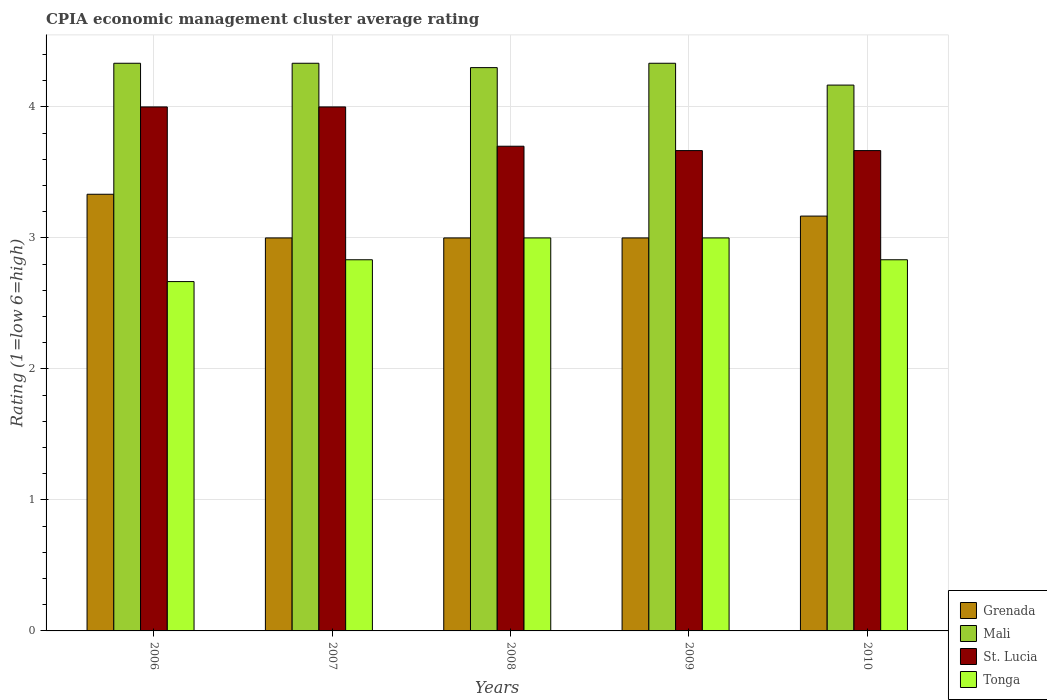How many different coloured bars are there?
Your answer should be very brief. 4. Are the number of bars per tick equal to the number of legend labels?
Keep it short and to the point. Yes. How many bars are there on the 2nd tick from the left?
Provide a short and direct response. 4. What is the CPIA rating in Mali in 2010?
Offer a terse response. 4.17. Across all years, what is the maximum CPIA rating in St. Lucia?
Provide a short and direct response. 4. In which year was the CPIA rating in Mali minimum?
Provide a short and direct response. 2010. What is the total CPIA rating in Tonga in the graph?
Give a very brief answer. 14.33. What is the difference between the CPIA rating in Mali in 2006 and that in 2008?
Give a very brief answer. 0.03. What is the difference between the CPIA rating in Grenada in 2008 and the CPIA rating in Tonga in 2007?
Offer a terse response. 0.17. What is the average CPIA rating in Mali per year?
Offer a very short reply. 4.29. In the year 2006, what is the difference between the CPIA rating in Mali and CPIA rating in Tonga?
Ensure brevity in your answer.  1.67. What is the ratio of the CPIA rating in Grenada in 2008 to that in 2010?
Ensure brevity in your answer.  0.95. What is the difference between the highest and the second highest CPIA rating in Grenada?
Your response must be concise. 0.17. What is the difference between the highest and the lowest CPIA rating in Tonga?
Provide a succinct answer. 0.33. In how many years, is the CPIA rating in Tonga greater than the average CPIA rating in Tonga taken over all years?
Your response must be concise. 2. Is the sum of the CPIA rating in St. Lucia in 2006 and 2008 greater than the maximum CPIA rating in Mali across all years?
Offer a very short reply. Yes. Is it the case that in every year, the sum of the CPIA rating in Grenada and CPIA rating in Tonga is greater than the sum of CPIA rating in St. Lucia and CPIA rating in Mali?
Keep it short and to the point. No. What does the 1st bar from the left in 2007 represents?
Make the answer very short. Grenada. What does the 4th bar from the right in 2006 represents?
Your answer should be very brief. Grenada. Are all the bars in the graph horizontal?
Give a very brief answer. No. What is the difference between two consecutive major ticks on the Y-axis?
Ensure brevity in your answer.  1. Are the values on the major ticks of Y-axis written in scientific E-notation?
Ensure brevity in your answer.  No. Does the graph contain any zero values?
Provide a succinct answer. No. Does the graph contain grids?
Make the answer very short. Yes. Where does the legend appear in the graph?
Keep it short and to the point. Bottom right. How are the legend labels stacked?
Offer a terse response. Vertical. What is the title of the graph?
Provide a succinct answer. CPIA economic management cluster average rating. What is the label or title of the Y-axis?
Ensure brevity in your answer.  Rating (1=low 6=high). What is the Rating (1=low 6=high) in Grenada in 2006?
Give a very brief answer. 3.33. What is the Rating (1=low 6=high) in Mali in 2006?
Your answer should be very brief. 4.33. What is the Rating (1=low 6=high) in St. Lucia in 2006?
Give a very brief answer. 4. What is the Rating (1=low 6=high) in Tonga in 2006?
Your answer should be very brief. 2.67. What is the Rating (1=low 6=high) in Mali in 2007?
Your answer should be very brief. 4.33. What is the Rating (1=low 6=high) in St. Lucia in 2007?
Your response must be concise. 4. What is the Rating (1=low 6=high) in Tonga in 2007?
Offer a very short reply. 2.83. What is the Rating (1=low 6=high) in Mali in 2008?
Give a very brief answer. 4.3. What is the Rating (1=low 6=high) in Mali in 2009?
Offer a terse response. 4.33. What is the Rating (1=low 6=high) in St. Lucia in 2009?
Your answer should be compact. 3.67. What is the Rating (1=low 6=high) in Tonga in 2009?
Make the answer very short. 3. What is the Rating (1=low 6=high) of Grenada in 2010?
Give a very brief answer. 3.17. What is the Rating (1=low 6=high) of Mali in 2010?
Keep it short and to the point. 4.17. What is the Rating (1=low 6=high) of St. Lucia in 2010?
Make the answer very short. 3.67. What is the Rating (1=low 6=high) in Tonga in 2010?
Keep it short and to the point. 2.83. Across all years, what is the maximum Rating (1=low 6=high) of Grenada?
Provide a succinct answer. 3.33. Across all years, what is the maximum Rating (1=low 6=high) in Mali?
Keep it short and to the point. 4.33. Across all years, what is the minimum Rating (1=low 6=high) of Mali?
Give a very brief answer. 4.17. Across all years, what is the minimum Rating (1=low 6=high) of St. Lucia?
Offer a terse response. 3.67. Across all years, what is the minimum Rating (1=low 6=high) of Tonga?
Your answer should be compact. 2.67. What is the total Rating (1=low 6=high) of Mali in the graph?
Keep it short and to the point. 21.47. What is the total Rating (1=low 6=high) in St. Lucia in the graph?
Give a very brief answer. 19.03. What is the total Rating (1=low 6=high) in Tonga in the graph?
Provide a succinct answer. 14.33. What is the difference between the Rating (1=low 6=high) of Grenada in 2006 and that in 2008?
Your answer should be compact. 0.33. What is the difference between the Rating (1=low 6=high) in Mali in 2006 and that in 2008?
Your response must be concise. 0.03. What is the difference between the Rating (1=low 6=high) in St. Lucia in 2006 and that in 2008?
Your response must be concise. 0.3. What is the difference between the Rating (1=low 6=high) in Tonga in 2006 and that in 2008?
Make the answer very short. -0.33. What is the difference between the Rating (1=low 6=high) in Mali in 2006 and that in 2009?
Your answer should be very brief. 0. What is the difference between the Rating (1=low 6=high) in St. Lucia in 2006 and that in 2009?
Ensure brevity in your answer.  0.33. What is the difference between the Rating (1=low 6=high) in Tonga in 2006 and that in 2009?
Keep it short and to the point. -0.33. What is the difference between the Rating (1=low 6=high) in Grenada in 2006 and that in 2010?
Your response must be concise. 0.17. What is the difference between the Rating (1=low 6=high) in Mali in 2006 and that in 2010?
Your answer should be very brief. 0.17. What is the difference between the Rating (1=low 6=high) in St. Lucia in 2006 and that in 2010?
Give a very brief answer. 0.33. What is the difference between the Rating (1=low 6=high) in St. Lucia in 2007 and that in 2008?
Offer a terse response. 0.3. What is the difference between the Rating (1=low 6=high) in Grenada in 2007 and that in 2009?
Keep it short and to the point. 0. What is the difference between the Rating (1=low 6=high) in Grenada in 2007 and that in 2010?
Your response must be concise. -0.17. What is the difference between the Rating (1=low 6=high) in St. Lucia in 2007 and that in 2010?
Your answer should be compact. 0.33. What is the difference between the Rating (1=low 6=high) in Grenada in 2008 and that in 2009?
Provide a short and direct response. 0. What is the difference between the Rating (1=low 6=high) in Mali in 2008 and that in 2009?
Ensure brevity in your answer.  -0.03. What is the difference between the Rating (1=low 6=high) of St. Lucia in 2008 and that in 2009?
Give a very brief answer. 0.03. What is the difference between the Rating (1=low 6=high) in Grenada in 2008 and that in 2010?
Offer a terse response. -0.17. What is the difference between the Rating (1=low 6=high) in Mali in 2008 and that in 2010?
Give a very brief answer. 0.13. What is the difference between the Rating (1=low 6=high) of Grenada in 2009 and that in 2010?
Keep it short and to the point. -0.17. What is the difference between the Rating (1=low 6=high) of Mali in 2009 and that in 2010?
Make the answer very short. 0.17. What is the difference between the Rating (1=low 6=high) in Tonga in 2009 and that in 2010?
Your answer should be compact. 0.17. What is the difference between the Rating (1=low 6=high) of Grenada in 2006 and the Rating (1=low 6=high) of St. Lucia in 2007?
Offer a terse response. -0.67. What is the difference between the Rating (1=low 6=high) in Grenada in 2006 and the Rating (1=low 6=high) in Mali in 2008?
Ensure brevity in your answer.  -0.97. What is the difference between the Rating (1=low 6=high) in Grenada in 2006 and the Rating (1=low 6=high) in St. Lucia in 2008?
Your answer should be very brief. -0.37. What is the difference between the Rating (1=low 6=high) of Grenada in 2006 and the Rating (1=low 6=high) of Tonga in 2008?
Your response must be concise. 0.33. What is the difference between the Rating (1=low 6=high) of Mali in 2006 and the Rating (1=low 6=high) of St. Lucia in 2008?
Offer a terse response. 0.63. What is the difference between the Rating (1=low 6=high) of Grenada in 2006 and the Rating (1=low 6=high) of Mali in 2009?
Give a very brief answer. -1. What is the difference between the Rating (1=low 6=high) of Grenada in 2006 and the Rating (1=low 6=high) of St. Lucia in 2009?
Your answer should be compact. -0.33. What is the difference between the Rating (1=low 6=high) of Grenada in 2006 and the Rating (1=low 6=high) of Tonga in 2009?
Your answer should be very brief. 0.33. What is the difference between the Rating (1=low 6=high) in Mali in 2006 and the Rating (1=low 6=high) in St. Lucia in 2009?
Offer a very short reply. 0.67. What is the difference between the Rating (1=low 6=high) in Mali in 2006 and the Rating (1=low 6=high) in Tonga in 2009?
Offer a very short reply. 1.33. What is the difference between the Rating (1=low 6=high) in St. Lucia in 2006 and the Rating (1=low 6=high) in Tonga in 2009?
Offer a terse response. 1. What is the difference between the Rating (1=low 6=high) in Grenada in 2006 and the Rating (1=low 6=high) in Mali in 2010?
Offer a very short reply. -0.83. What is the difference between the Rating (1=low 6=high) in Mali in 2006 and the Rating (1=low 6=high) in St. Lucia in 2010?
Offer a terse response. 0.67. What is the difference between the Rating (1=low 6=high) in Grenada in 2007 and the Rating (1=low 6=high) in Mali in 2008?
Give a very brief answer. -1.3. What is the difference between the Rating (1=low 6=high) of Grenada in 2007 and the Rating (1=low 6=high) of St. Lucia in 2008?
Your answer should be compact. -0.7. What is the difference between the Rating (1=low 6=high) in Mali in 2007 and the Rating (1=low 6=high) in St. Lucia in 2008?
Keep it short and to the point. 0.63. What is the difference between the Rating (1=low 6=high) in Mali in 2007 and the Rating (1=low 6=high) in Tonga in 2008?
Keep it short and to the point. 1.33. What is the difference between the Rating (1=low 6=high) in St. Lucia in 2007 and the Rating (1=low 6=high) in Tonga in 2008?
Offer a very short reply. 1. What is the difference between the Rating (1=low 6=high) of Grenada in 2007 and the Rating (1=low 6=high) of Mali in 2009?
Your response must be concise. -1.33. What is the difference between the Rating (1=low 6=high) in Grenada in 2007 and the Rating (1=low 6=high) in St. Lucia in 2009?
Your answer should be compact. -0.67. What is the difference between the Rating (1=low 6=high) in Grenada in 2007 and the Rating (1=low 6=high) in Tonga in 2009?
Keep it short and to the point. 0. What is the difference between the Rating (1=low 6=high) of Mali in 2007 and the Rating (1=low 6=high) of Tonga in 2009?
Give a very brief answer. 1.33. What is the difference between the Rating (1=low 6=high) of St. Lucia in 2007 and the Rating (1=low 6=high) of Tonga in 2009?
Provide a succinct answer. 1. What is the difference between the Rating (1=low 6=high) of Grenada in 2007 and the Rating (1=low 6=high) of Mali in 2010?
Your answer should be compact. -1.17. What is the difference between the Rating (1=low 6=high) in Grenada in 2007 and the Rating (1=low 6=high) in St. Lucia in 2010?
Offer a very short reply. -0.67. What is the difference between the Rating (1=low 6=high) in Grenada in 2007 and the Rating (1=low 6=high) in Tonga in 2010?
Your response must be concise. 0.17. What is the difference between the Rating (1=low 6=high) of Mali in 2007 and the Rating (1=low 6=high) of Tonga in 2010?
Ensure brevity in your answer.  1.5. What is the difference between the Rating (1=low 6=high) of St. Lucia in 2007 and the Rating (1=low 6=high) of Tonga in 2010?
Make the answer very short. 1.17. What is the difference between the Rating (1=low 6=high) in Grenada in 2008 and the Rating (1=low 6=high) in Mali in 2009?
Offer a very short reply. -1.33. What is the difference between the Rating (1=low 6=high) in Mali in 2008 and the Rating (1=low 6=high) in St. Lucia in 2009?
Make the answer very short. 0.63. What is the difference between the Rating (1=low 6=high) in Grenada in 2008 and the Rating (1=low 6=high) in Mali in 2010?
Offer a terse response. -1.17. What is the difference between the Rating (1=low 6=high) in Grenada in 2008 and the Rating (1=low 6=high) in Tonga in 2010?
Provide a short and direct response. 0.17. What is the difference between the Rating (1=low 6=high) in Mali in 2008 and the Rating (1=low 6=high) in St. Lucia in 2010?
Ensure brevity in your answer.  0.63. What is the difference between the Rating (1=low 6=high) of Mali in 2008 and the Rating (1=low 6=high) of Tonga in 2010?
Keep it short and to the point. 1.47. What is the difference between the Rating (1=low 6=high) of St. Lucia in 2008 and the Rating (1=low 6=high) of Tonga in 2010?
Your answer should be compact. 0.87. What is the difference between the Rating (1=low 6=high) of Grenada in 2009 and the Rating (1=low 6=high) of Mali in 2010?
Keep it short and to the point. -1.17. What is the difference between the Rating (1=low 6=high) in Grenada in 2009 and the Rating (1=low 6=high) in St. Lucia in 2010?
Keep it short and to the point. -0.67. What is the difference between the Rating (1=low 6=high) of Grenada in 2009 and the Rating (1=low 6=high) of Tonga in 2010?
Your answer should be compact. 0.17. What is the average Rating (1=low 6=high) of Mali per year?
Offer a very short reply. 4.29. What is the average Rating (1=low 6=high) in St. Lucia per year?
Your answer should be very brief. 3.81. What is the average Rating (1=low 6=high) of Tonga per year?
Ensure brevity in your answer.  2.87. In the year 2006, what is the difference between the Rating (1=low 6=high) in Grenada and Rating (1=low 6=high) in Mali?
Your answer should be compact. -1. In the year 2006, what is the difference between the Rating (1=low 6=high) of Grenada and Rating (1=low 6=high) of Tonga?
Offer a terse response. 0.67. In the year 2006, what is the difference between the Rating (1=low 6=high) in Mali and Rating (1=low 6=high) in St. Lucia?
Ensure brevity in your answer.  0.33. In the year 2006, what is the difference between the Rating (1=low 6=high) of Mali and Rating (1=low 6=high) of Tonga?
Offer a terse response. 1.67. In the year 2007, what is the difference between the Rating (1=low 6=high) of Grenada and Rating (1=low 6=high) of Mali?
Your answer should be compact. -1.33. In the year 2007, what is the difference between the Rating (1=low 6=high) in Grenada and Rating (1=low 6=high) in St. Lucia?
Provide a short and direct response. -1. In the year 2007, what is the difference between the Rating (1=low 6=high) in Mali and Rating (1=low 6=high) in Tonga?
Give a very brief answer. 1.5. In the year 2007, what is the difference between the Rating (1=low 6=high) of St. Lucia and Rating (1=low 6=high) of Tonga?
Give a very brief answer. 1.17. In the year 2008, what is the difference between the Rating (1=low 6=high) of Grenada and Rating (1=low 6=high) of Mali?
Offer a very short reply. -1.3. In the year 2008, what is the difference between the Rating (1=low 6=high) of Grenada and Rating (1=low 6=high) of St. Lucia?
Offer a very short reply. -0.7. In the year 2008, what is the difference between the Rating (1=low 6=high) of Mali and Rating (1=low 6=high) of Tonga?
Keep it short and to the point. 1.3. In the year 2009, what is the difference between the Rating (1=low 6=high) in Grenada and Rating (1=low 6=high) in Mali?
Offer a very short reply. -1.33. In the year 2009, what is the difference between the Rating (1=low 6=high) in Grenada and Rating (1=low 6=high) in Tonga?
Your answer should be very brief. 0. In the year 2009, what is the difference between the Rating (1=low 6=high) in Mali and Rating (1=low 6=high) in St. Lucia?
Your response must be concise. 0.67. In the year 2010, what is the difference between the Rating (1=low 6=high) in Mali and Rating (1=low 6=high) in St. Lucia?
Give a very brief answer. 0.5. In the year 2010, what is the difference between the Rating (1=low 6=high) of Mali and Rating (1=low 6=high) of Tonga?
Your answer should be very brief. 1.33. What is the ratio of the Rating (1=low 6=high) in St. Lucia in 2006 to that in 2007?
Provide a succinct answer. 1. What is the ratio of the Rating (1=low 6=high) of Tonga in 2006 to that in 2007?
Your answer should be compact. 0.94. What is the ratio of the Rating (1=low 6=high) in Mali in 2006 to that in 2008?
Your answer should be very brief. 1.01. What is the ratio of the Rating (1=low 6=high) in St. Lucia in 2006 to that in 2008?
Your answer should be very brief. 1.08. What is the ratio of the Rating (1=low 6=high) of Mali in 2006 to that in 2009?
Your response must be concise. 1. What is the ratio of the Rating (1=low 6=high) in Grenada in 2006 to that in 2010?
Your response must be concise. 1.05. What is the ratio of the Rating (1=low 6=high) of Mali in 2006 to that in 2010?
Your answer should be very brief. 1.04. What is the ratio of the Rating (1=low 6=high) in St. Lucia in 2006 to that in 2010?
Give a very brief answer. 1.09. What is the ratio of the Rating (1=low 6=high) in Tonga in 2006 to that in 2010?
Give a very brief answer. 0.94. What is the ratio of the Rating (1=low 6=high) in Mali in 2007 to that in 2008?
Provide a short and direct response. 1.01. What is the ratio of the Rating (1=low 6=high) of St. Lucia in 2007 to that in 2008?
Your answer should be compact. 1.08. What is the ratio of the Rating (1=low 6=high) of Grenada in 2007 to that in 2009?
Make the answer very short. 1. What is the ratio of the Rating (1=low 6=high) of St. Lucia in 2007 to that in 2009?
Provide a succinct answer. 1.09. What is the ratio of the Rating (1=low 6=high) in St. Lucia in 2007 to that in 2010?
Offer a terse response. 1.09. What is the ratio of the Rating (1=low 6=high) of Tonga in 2007 to that in 2010?
Your answer should be compact. 1. What is the ratio of the Rating (1=low 6=high) in St. Lucia in 2008 to that in 2009?
Your response must be concise. 1.01. What is the ratio of the Rating (1=low 6=high) in Grenada in 2008 to that in 2010?
Your answer should be compact. 0.95. What is the ratio of the Rating (1=low 6=high) of Mali in 2008 to that in 2010?
Your response must be concise. 1.03. What is the ratio of the Rating (1=low 6=high) in St. Lucia in 2008 to that in 2010?
Offer a very short reply. 1.01. What is the ratio of the Rating (1=low 6=high) of Tonga in 2008 to that in 2010?
Keep it short and to the point. 1.06. What is the ratio of the Rating (1=low 6=high) in Grenada in 2009 to that in 2010?
Keep it short and to the point. 0.95. What is the ratio of the Rating (1=low 6=high) of Mali in 2009 to that in 2010?
Ensure brevity in your answer.  1.04. What is the ratio of the Rating (1=low 6=high) of Tonga in 2009 to that in 2010?
Give a very brief answer. 1.06. What is the difference between the highest and the second highest Rating (1=low 6=high) in Grenada?
Provide a succinct answer. 0.17. What is the difference between the highest and the second highest Rating (1=low 6=high) of St. Lucia?
Give a very brief answer. 0. What is the difference between the highest and the second highest Rating (1=low 6=high) of Tonga?
Your answer should be very brief. 0. What is the difference between the highest and the lowest Rating (1=low 6=high) of Grenada?
Give a very brief answer. 0.33. What is the difference between the highest and the lowest Rating (1=low 6=high) in St. Lucia?
Provide a short and direct response. 0.33. 